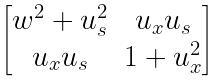Convert formula to latex. <formula><loc_0><loc_0><loc_500><loc_500>\begin{bmatrix} w ^ { 2 } + u _ { s } ^ { 2 } & u _ { x } u _ { s } \\ u _ { x } u _ { s } & 1 + u _ { x } ^ { 2 } \end{bmatrix}</formula> 